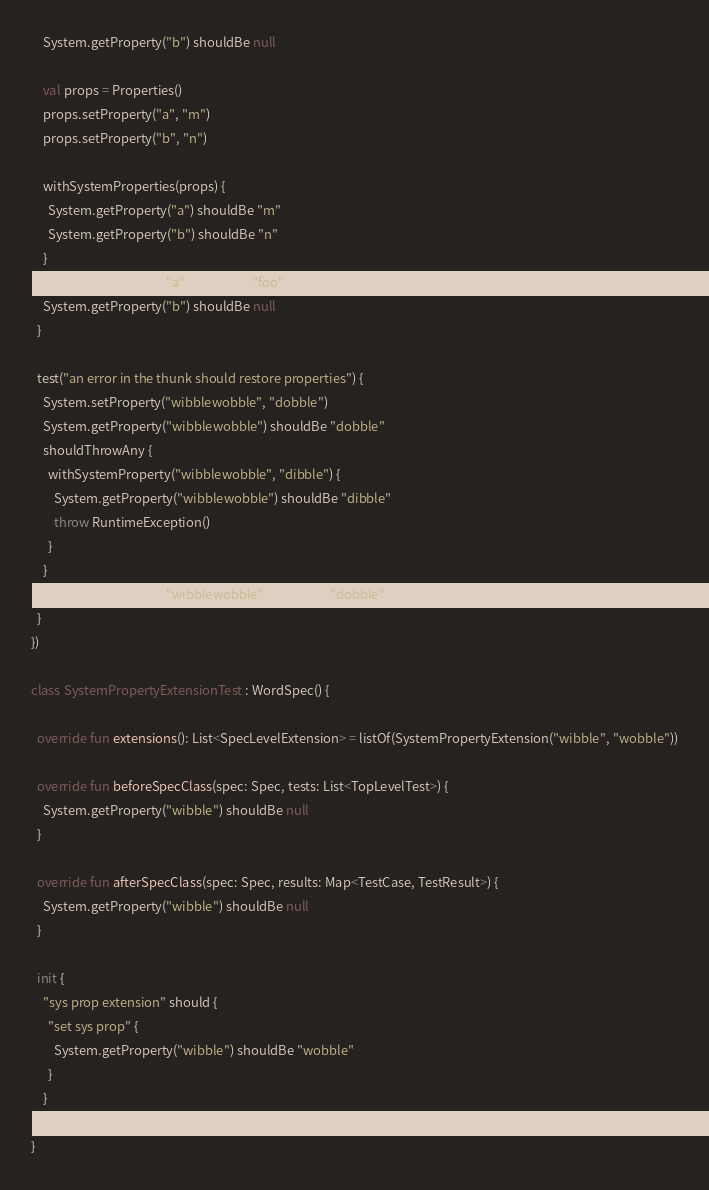<code> <loc_0><loc_0><loc_500><loc_500><_Kotlin_>    System.getProperty("b") shouldBe null

    val props = Properties()
    props.setProperty("a", "m")
    props.setProperty("b", "n")

    withSystemProperties(props) {
      System.getProperty("a") shouldBe "m"
      System.getProperty("b") shouldBe "n"
    }
    System.getProperty("a") shouldBe "foo"
    System.getProperty("b") shouldBe null
  }

  test("an error in the thunk should restore properties") {
    System.setProperty("wibblewobble", "dobble")
    System.getProperty("wibblewobble") shouldBe "dobble"
    shouldThrowAny {
      withSystemProperty("wibblewobble", "dibble") {
        System.getProperty("wibblewobble") shouldBe "dibble"
        throw RuntimeException()
      }
    }
    System.getProperty("wibblewobble") shouldBe "dobble"
  }
})

class SystemPropertyExtensionTest : WordSpec() {

  override fun extensions(): List<SpecLevelExtension> = listOf(SystemPropertyExtension("wibble", "wobble"))

  override fun beforeSpecClass(spec: Spec, tests: List<TopLevelTest>) {
    System.getProperty("wibble") shouldBe null
  }

  override fun afterSpecClass(spec: Spec, results: Map<TestCase, TestResult>) {
    System.getProperty("wibble") shouldBe null
  }

  init {
    "sys prop extension" should {
      "set sys prop" {
        System.getProperty("wibble") shouldBe "wobble"
      }
    }
  }
}</code> 